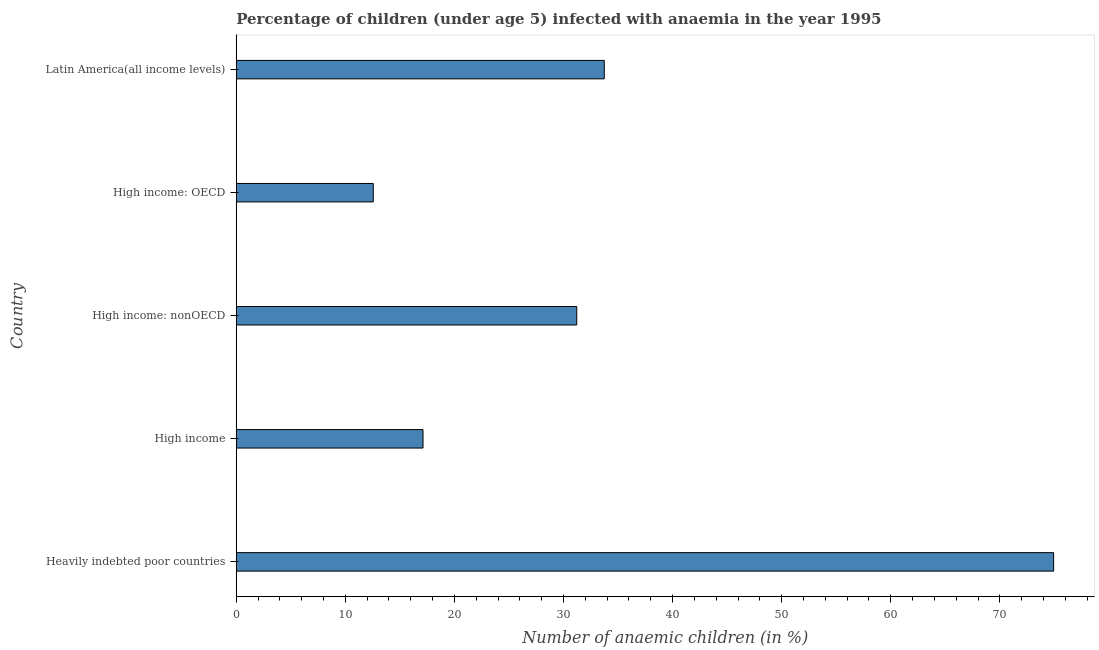What is the title of the graph?
Keep it short and to the point. Percentage of children (under age 5) infected with anaemia in the year 1995. What is the label or title of the X-axis?
Your response must be concise. Number of anaemic children (in %). What is the label or title of the Y-axis?
Provide a short and direct response. Country. What is the number of anaemic children in Latin America(all income levels)?
Your answer should be very brief. 33.74. Across all countries, what is the maximum number of anaemic children?
Keep it short and to the point. 74.93. Across all countries, what is the minimum number of anaemic children?
Provide a short and direct response. 12.56. In which country was the number of anaemic children maximum?
Your answer should be compact. Heavily indebted poor countries. In which country was the number of anaemic children minimum?
Provide a short and direct response. High income: OECD. What is the sum of the number of anaemic children?
Your response must be concise. 169.56. What is the difference between the number of anaemic children in High income: nonOECD and Latin America(all income levels)?
Your response must be concise. -2.52. What is the average number of anaemic children per country?
Provide a succinct answer. 33.91. What is the median number of anaemic children?
Provide a short and direct response. 31.21. In how many countries, is the number of anaemic children greater than 66 %?
Offer a very short reply. 1. What is the ratio of the number of anaemic children in Heavily indebted poor countries to that in High income: OECD?
Offer a terse response. 5.97. Is the difference between the number of anaemic children in High income: nonOECD and Latin America(all income levels) greater than the difference between any two countries?
Your response must be concise. No. What is the difference between the highest and the second highest number of anaemic children?
Provide a short and direct response. 41.19. Is the sum of the number of anaemic children in High income and Latin America(all income levels) greater than the maximum number of anaemic children across all countries?
Make the answer very short. No. What is the difference between the highest and the lowest number of anaemic children?
Provide a succinct answer. 62.37. In how many countries, is the number of anaemic children greater than the average number of anaemic children taken over all countries?
Make the answer very short. 1. Are all the bars in the graph horizontal?
Ensure brevity in your answer.  Yes. How many countries are there in the graph?
Give a very brief answer. 5. What is the difference between two consecutive major ticks on the X-axis?
Offer a terse response. 10. Are the values on the major ticks of X-axis written in scientific E-notation?
Your answer should be very brief. No. What is the Number of anaemic children (in %) of Heavily indebted poor countries?
Offer a very short reply. 74.93. What is the Number of anaemic children (in %) in High income?
Make the answer very short. 17.12. What is the Number of anaemic children (in %) of High income: nonOECD?
Give a very brief answer. 31.21. What is the Number of anaemic children (in %) in High income: OECD?
Keep it short and to the point. 12.56. What is the Number of anaemic children (in %) in Latin America(all income levels)?
Keep it short and to the point. 33.74. What is the difference between the Number of anaemic children (in %) in Heavily indebted poor countries and High income?
Your answer should be very brief. 57.81. What is the difference between the Number of anaemic children (in %) in Heavily indebted poor countries and High income: nonOECD?
Make the answer very short. 43.72. What is the difference between the Number of anaemic children (in %) in Heavily indebted poor countries and High income: OECD?
Make the answer very short. 62.37. What is the difference between the Number of anaemic children (in %) in Heavily indebted poor countries and Latin America(all income levels)?
Offer a very short reply. 41.19. What is the difference between the Number of anaemic children (in %) in High income and High income: nonOECD?
Your answer should be very brief. -14.09. What is the difference between the Number of anaemic children (in %) in High income and High income: OECD?
Your answer should be compact. 4.56. What is the difference between the Number of anaemic children (in %) in High income and Latin America(all income levels)?
Make the answer very short. -16.61. What is the difference between the Number of anaemic children (in %) in High income: nonOECD and High income: OECD?
Provide a succinct answer. 18.65. What is the difference between the Number of anaemic children (in %) in High income: nonOECD and Latin America(all income levels)?
Ensure brevity in your answer.  -2.52. What is the difference between the Number of anaemic children (in %) in High income: OECD and Latin America(all income levels)?
Keep it short and to the point. -21.18. What is the ratio of the Number of anaemic children (in %) in Heavily indebted poor countries to that in High income?
Make the answer very short. 4.38. What is the ratio of the Number of anaemic children (in %) in Heavily indebted poor countries to that in High income: nonOECD?
Offer a terse response. 2.4. What is the ratio of the Number of anaemic children (in %) in Heavily indebted poor countries to that in High income: OECD?
Keep it short and to the point. 5.97. What is the ratio of the Number of anaemic children (in %) in Heavily indebted poor countries to that in Latin America(all income levels)?
Your answer should be very brief. 2.22. What is the ratio of the Number of anaemic children (in %) in High income to that in High income: nonOECD?
Offer a very short reply. 0.55. What is the ratio of the Number of anaemic children (in %) in High income to that in High income: OECD?
Ensure brevity in your answer.  1.36. What is the ratio of the Number of anaemic children (in %) in High income to that in Latin America(all income levels)?
Your answer should be very brief. 0.51. What is the ratio of the Number of anaemic children (in %) in High income: nonOECD to that in High income: OECD?
Your answer should be compact. 2.48. What is the ratio of the Number of anaemic children (in %) in High income: nonOECD to that in Latin America(all income levels)?
Provide a succinct answer. 0.93. What is the ratio of the Number of anaemic children (in %) in High income: OECD to that in Latin America(all income levels)?
Ensure brevity in your answer.  0.37. 